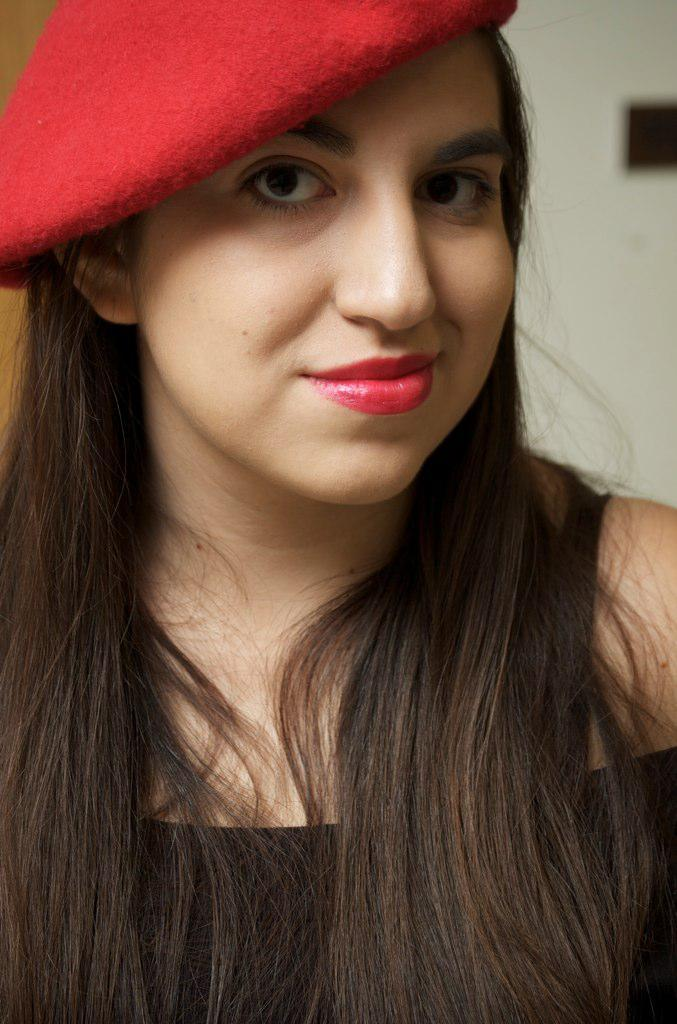Who is present in the image? There is a woman in the image. What is the woman wearing on her head? The woman is wearing a red cap. What can be seen in the background of the image? There is a white wall in the image. What is on the white wall? There is a black object on the white wall. What type of property does the woman own in the image? There is no information about property ownership in the image. How many knees can be seen in the image? There is no mention of knees in the image; it only features a woman and a white wall with a black object. 